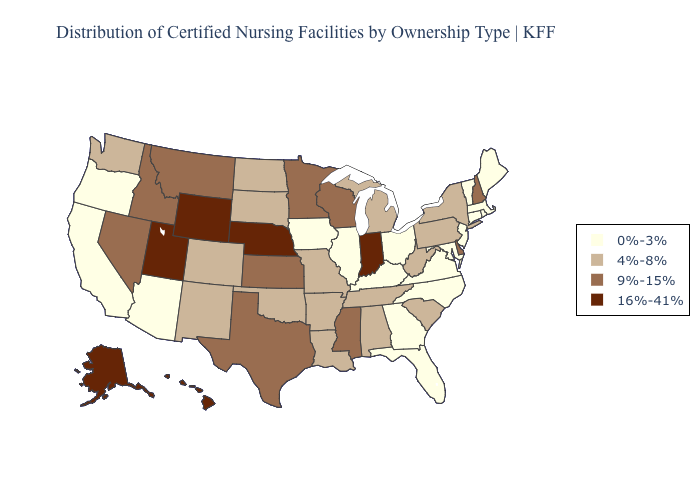Which states have the highest value in the USA?
Be succinct. Alaska, Hawaii, Indiana, Nebraska, Utah, Wyoming. Does Vermont have the lowest value in the USA?
Write a very short answer. Yes. Name the states that have a value in the range 16%-41%?
Keep it brief. Alaska, Hawaii, Indiana, Nebraska, Utah, Wyoming. Among the states that border Alabama , does Tennessee have the highest value?
Write a very short answer. No. Does North Carolina have the same value as New Mexico?
Concise answer only. No. What is the value of Ohio?
Answer briefly. 0%-3%. Does Georgia have the highest value in the USA?
Concise answer only. No. Does the map have missing data?
Be succinct. No. Does Kansas have the highest value in the MidWest?
Short answer required. No. Name the states that have a value in the range 0%-3%?
Quick response, please. Arizona, California, Connecticut, Florida, Georgia, Illinois, Iowa, Kentucky, Maine, Maryland, Massachusetts, New Jersey, North Carolina, Ohio, Oregon, Rhode Island, Vermont, Virginia. Name the states that have a value in the range 0%-3%?
Write a very short answer. Arizona, California, Connecticut, Florida, Georgia, Illinois, Iowa, Kentucky, Maine, Maryland, Massachusetts, New Jersey, North Carolina, Ohio, Oregon, Rhode Island, Vermont, Virginia. Which states have the highest value in the USA?
Short answer required. Alaska, Hawaii, Indiana, Nebraska, Utah, Wyoming. What is the highest value in the Northeast ?
Be succinct. 9%-15%. Does Oklahoma have the lowest value in the USA?
Answer briefly. No. What is the lowest value in the Northeast?
Quick response, please. 0%-3%. 